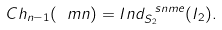Convert formula to latex. <formula><loc_0><loc_0><loc_500><loc_500>C h _ { n - 1 } ( \ m n ) = I n d ^ { \ s n m e } _ { S _ { 2 } } ( I _ { 2 } ) .</formula> 